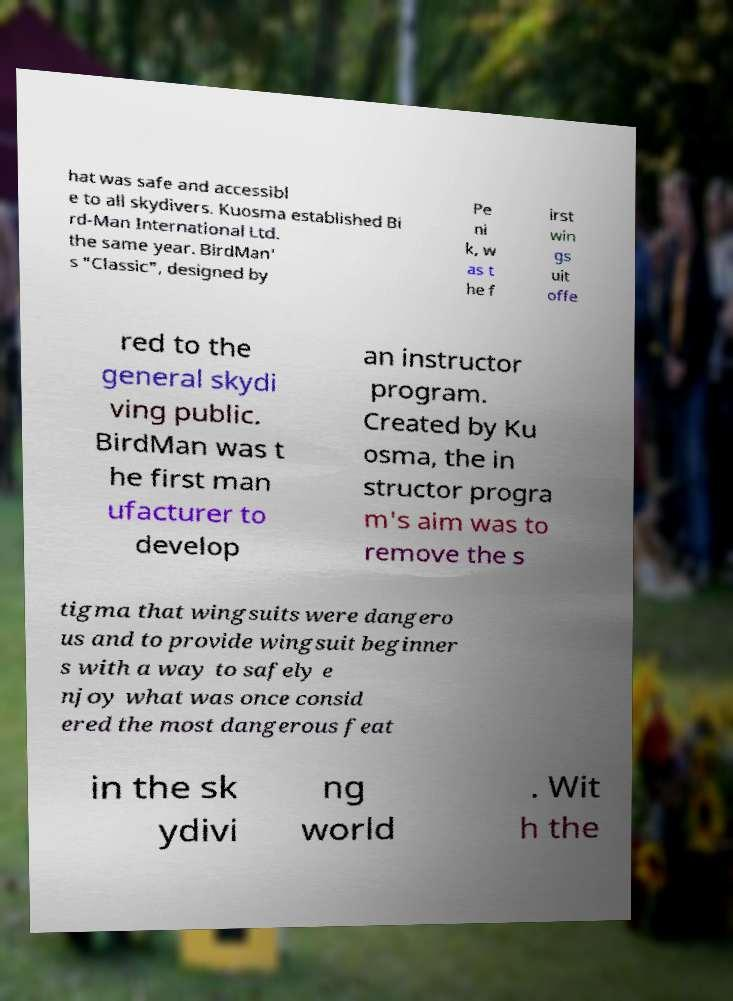Could you assist in decoding the text presented in this image and type it out clearly? hat was safe and accessibl e to all skydivers. Kuosma established Bi rd-Man International Ltd. the same year. BirdMan' s "Classic", designed by Pe ni k, w as t he f irst win gs uit offe red to the general skydi ving public. BirdMan was t he first man ufacturer to develop an instructor program. Created by Ku osma, the in structor progra m's aim was to remove the s tigma that wingsuits were dangero us and to provide wingsuit beginner s with a way to safely e njoy what was once consid ered the most dangerous feat in the sk ydivi ng world . Wit h the 